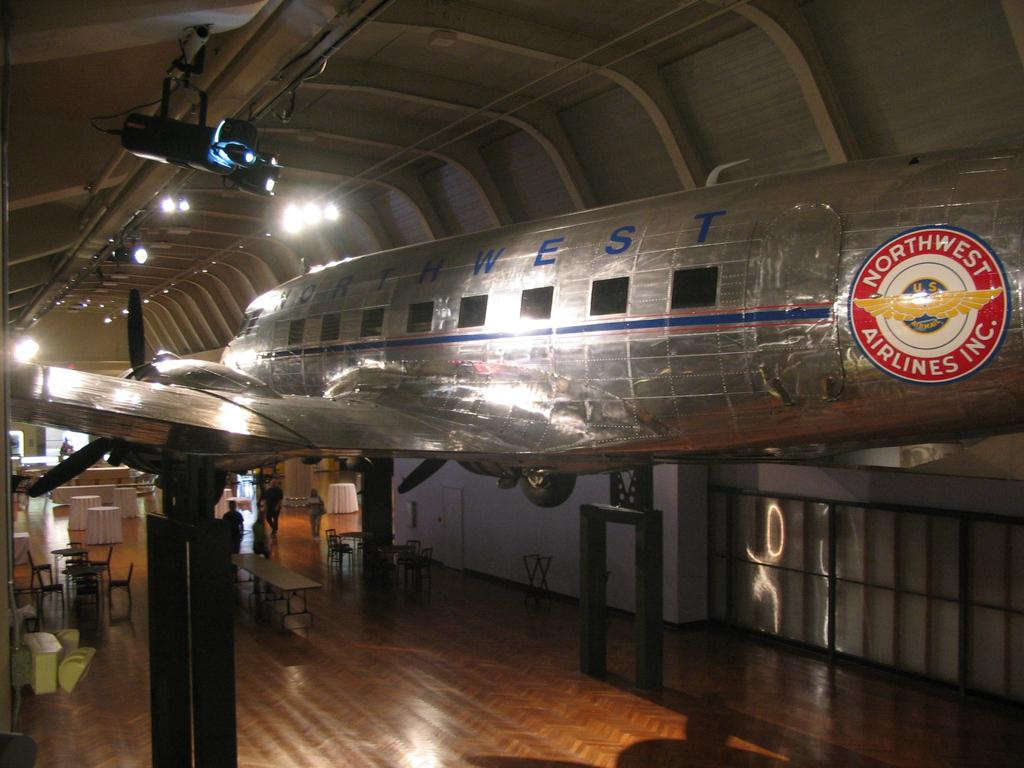<image>
Share a concise interpretation of the image provided. An antique Northwest airplane hangs above a room set up for an event. 